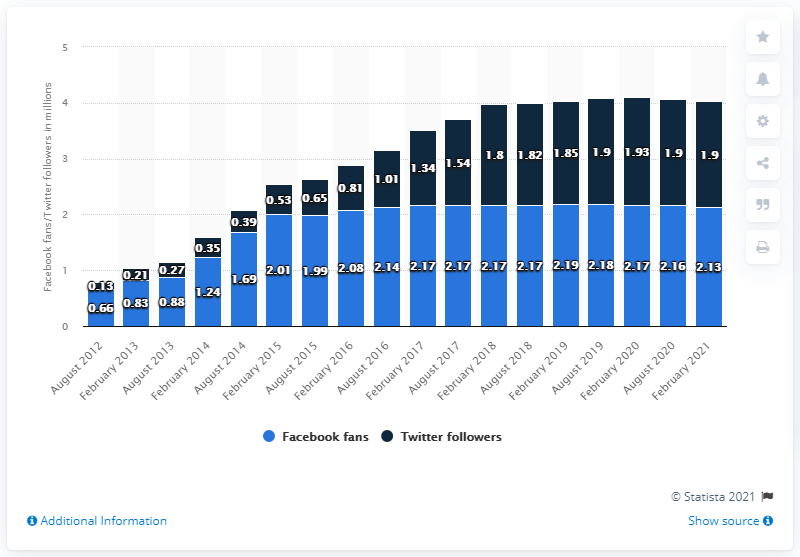Specify some key components in this picture. As of February 2021, the Houston Texans football team had approximately 2.13 million Facebook followers. On February 2021, the Houston Texans' Facebook page achieved 2.13 million followers. As of August 2012, the Houston Texans had a Facebook page. 